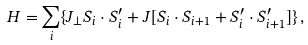<formula> <loc_0><loc_0><loc_500><loc_500>H = \sum _ { i } \{ J _ { \perp } { S } _ { i } \cdot { S } ^ { \prime } _ { i } + J [ { S } _ { i } \cdot { S } _ { i + 1 } + { S } _ { i } ^ { \prime } \cdot { S } ^ { \prime } _ { i + 1 } ] \} \, ,</formula> 